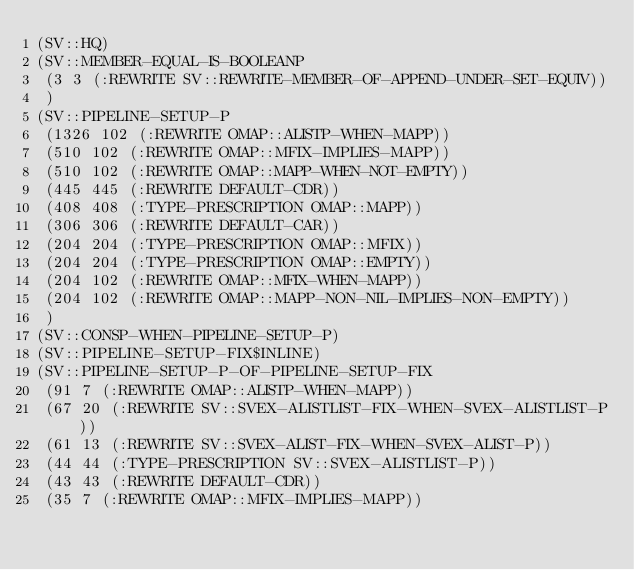Convert code to text. <code><loc_0><loc_0><loc_500><loc_500><_Lisp_>(SV::HQ)
(SV::MEMBER-EQUAL-IS-BOOLEANP
 (3 3 (:REWRITE SV::REWRITE-MEMBER-OF-APPEND-UNDER-SET-EQUIV))
 )
(SV::PIPELINE-SETUP-P
 (1326 102 (:REWRITE OMAP::ALISTP-WHEN-MAPP))
 (510 102 (:REWRITE OMAP::MFIX-IMPLIES-MAPP))
 (510 102 (:REWRITE OMAP::MAPP-WHEN-NOT-EMPTY))
 (445 445 (:REWRITE DEFAULT-CDR))
 (408 408 (:TYPE-PRESCRIPTION OMAP::MAPP))
 (306 306 (:REWRITE DEFAULT-CAR))
 (204 204 (:TYPE-PRESCRIPTION OMAP::MFIX))
 (204 204 (:TYPE-PRESCRIPTION OMAP::EMPTY))
 (204 102 (:REWRITE OMAP::MFIX-WHEN-MAPP))
 (204 102 (:REWRITE OMAP::MAPP-NON-NIL-IMPLIES-NON-EMPTY))
 )
(SV::CONSP-WHEN-PIPELINE-SETUP-P)
(SV::PIPELINE-SETUP-FIX$INLINE)
(SV::PIPELINE-SETUP-P-OF-PIPELINE-SETUP-FIX
 (91 7 (:REWRITE OMAP::ALISTP-WHEN-MAPP))
 (67 20 (:REWRITE SV::SVEX-ALISTLIST-FIX-WHEN-SVEX-ALISTLIST-P))
 (61 13 (:REWRITE SV::SVEX-ALIST-FIX-WHEN-SVEX-ALIST-P))
 (44 44 (:TYPE-PRESCRIPTION SV::SVEX-ALISTLIST-P))
 (43 43 (:REWRITE DEFAULT-CDR))
 (35 7 (:REWRITE OMAP::MFIX-IMPLIES-MAPP))</code> 